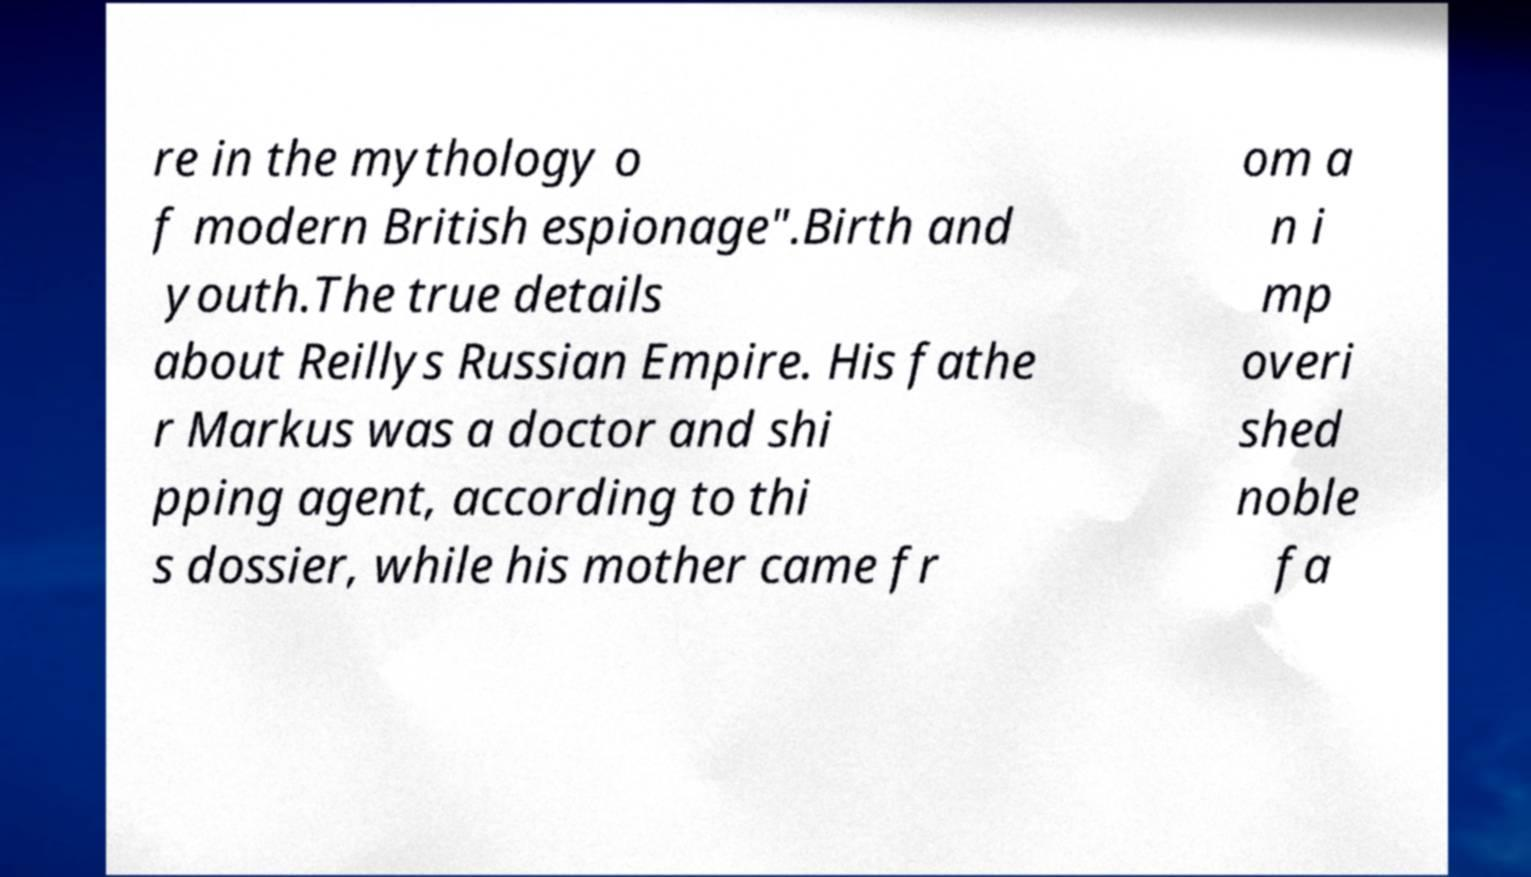I need the written content from this picture converted into text. Can you do that? re in the mythology o f modern British espionage".Birth and youth.The true details about Reillys Russian Empire. His fathe r Markus was a doctor and shi pping agent, according to thi s dossier, while his mother came fr om a n i mp overi shed noble fa 